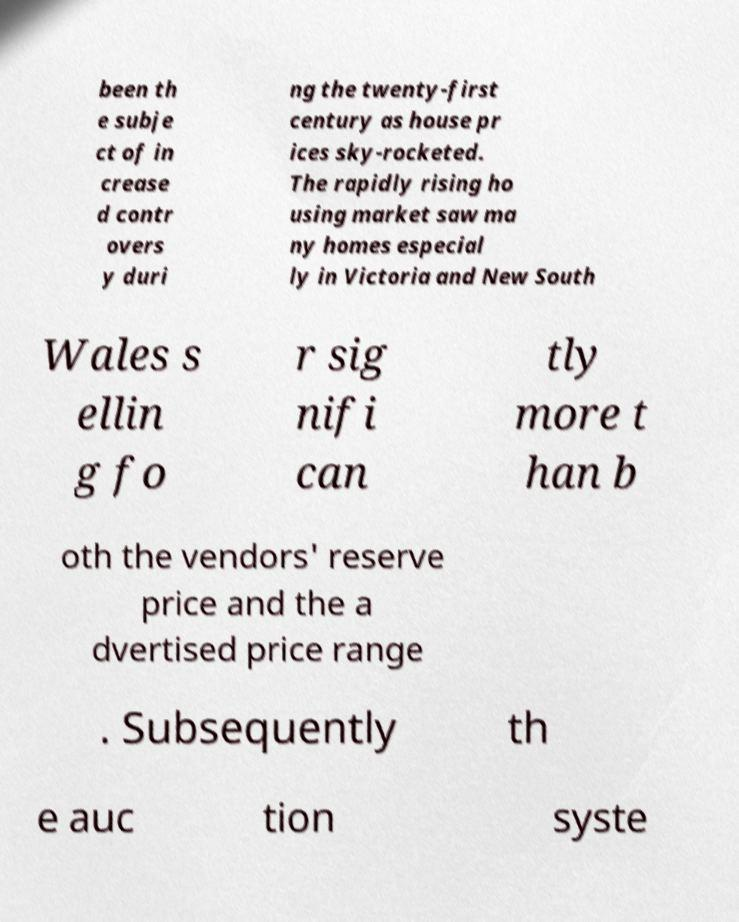Please read and relay the text visible in this image. What does it say? been th e subje ct of in crease d contr overs y duri ng the twenty-first century as house pr ices sky-rocketed. The rapidly rising ho using market saw ma ny homes especial ly in Victoria and New South Wales s ellin g fo r sig nifi can tly more t han b oth the vendors' reserve price and the a dvertised price range . Subsequently th e auc tion syste 